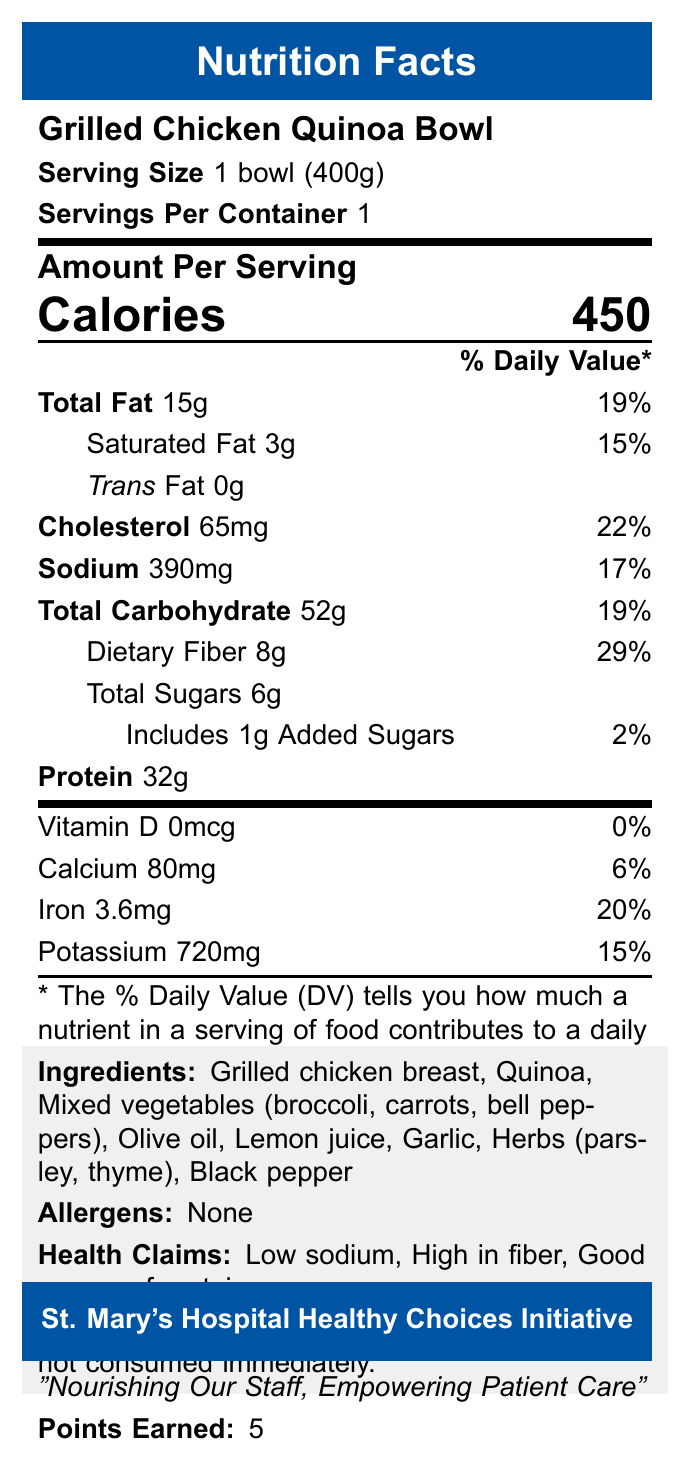What is the serving size of the Grilled Chicken Quinoa Bowl? The serving size is clearly stated as "1 bowl (400g)" on the Nutrition Facts label.
Answer: 1 bowl (400g) How many calories are in one serving of the Grilled Chicken Quinoa Bowl? The label specifies that the amount per serving is 450 calories.
Answer: 450 What percentage of the daily value of sodium is in the Grilled Chicken Quinoa Bowl? The label shows that the sodium content is 390mg, which is 17% of the daily value.
Answer: 17% How much dietary fiber is in the Grilled Chicken Quinoa Bowl? The label indicates that the dietary fiber content is 8g.
Answer: 8g How many grams of protein are in a serving of the Grilled Chicken Quinoa Bowl? The label states that the protein content is 32g.
Answer: 32g Which of the following is a health claim made about the Grilled Chicken Quinoa Bowl? A. Low in sugar B. Low sodium C. High in saturated fat D. Low in cholesterol The label lists "Low sodium" as one of the health claims.
Answer: B. Low sodium What percentage of the daily value of Vitamin D does the Grilled Chicken Quinoa Bowl provide? A. 0% B. 10% C. 50% D. 100% The label shows that the Vitamin D content is 0mcg, which is 0% of the daily value.
Answer: A. 0% Does the Grilled Chicken Quinoa Bowl contain any allergens? The label clearly states that there are no allergens.
Answer: No What is the slogan for St. Mary's Hospital Healthy Choices Initiative? The document includes the section title with the slogan "Nourishing Our Staff, Empowering Patient Care".
Answer: Nourishing Our Staff, Empowering Patient Care Does the Grilled Chicken Quinoa Bowl have more total fats or carbohydrates? The label indicates 15g of total fat and 52g of total carbohydrates.
Answer: Carbohydrates Summarize the main idea of the document. The summary can be crafted by synthesizing the different sections of the label, which include nutritional breakdown, ingredients, health claims, and hospital wellness program information.
Answer: The document presents the Nutrition Facts label for the Grilled Chicken Quinoa Bowl, a healthy cafeteria lunch option, highlighting its nutritional content, ingredients, health claims, allergen information, and its association with St. Mary's Hospital Healthy Choices Initiative. How much iron is in the Grilled Chicken Quinoa Bowl? The label shows that the iron content is 3.6mg.
Answer: 3.6mg What points are earned by choosing this meal under the hospital wellness program? The document mentions that this meal earns 5 points in St. Mary's Hospital Healthy Choices Initiative.
Answer: 5 points What is the daily value percentage for added sugars in the Grilled Chicken Quinoa Bowl? The label indicates that the added sugars content is 1g, which represents 2% of the daily value.
Answer: 2% How much potassium does the Grilled Chicken Quinoa Bowl contain? The label states that the potassium content is 720mg.
Answer: 720mg Can the exact number of servings per container be determined from the document? The label states "Servings Per Container: 1".
Answer: Yes 